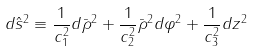<formula> <loc_0><loc_0><loc_500><loc_500>d \hat { s } ^ { 2 } \equiv \frac { 1 } { c _ { 1 } ^ { 2 } } d \bar { \rho } ^ { 2 } + \frac { 1 } { c _ { 2 } ^ { 2 } } \bar { \rho } ^ { 2 } d \varphi ^ { 2 } + \frac { 1 } { c _ { 3 } ^ { 2 } } d z ^ { 2 }</formula> 